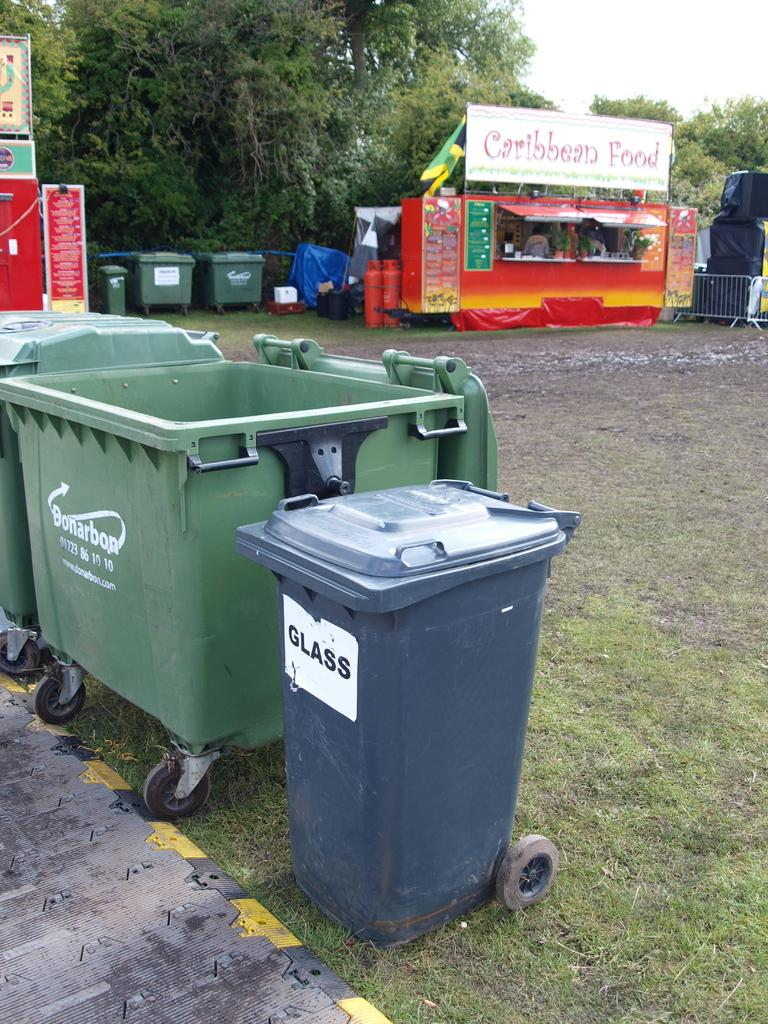Provide a one-sentence caption for the provided image. A stand that sells food of the Caribbean variety. 